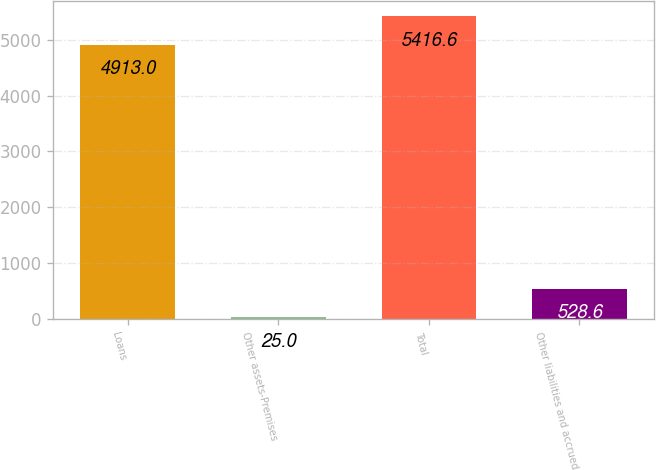<chart> <loc_0><loc_0><loc_500><loc_500><bar_chart><fcel>Loans<fcel>Other assets-Premises<fcel>Total<fcel>Other liabilities and accrued<nl><fcel>4913<fcel>25<fcel>5416.6<fcel>528.6<nl></chart> 